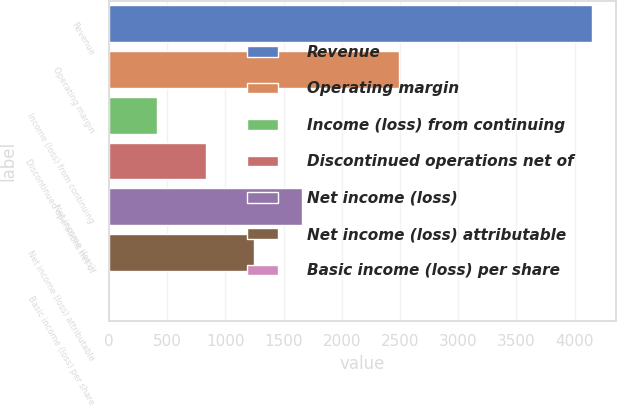<chart> <loc_0><loc_0><loc_500><loc_500><bar_chart><fcel>Revenue<fcel>Operating margin<fcel>Income (loss) from continuing<fcel>Discontinued operations net of<fcel>Net income (loss)<fcel>Net income (loss) attributable<fcel>Basic income (loss) per share<nl><fcel>4150<fcel>2490.05<fcel>415.1<fcel>830.09<fcel>1660.07<fcel>1245.08<fcel>0.11<nl></chart> 